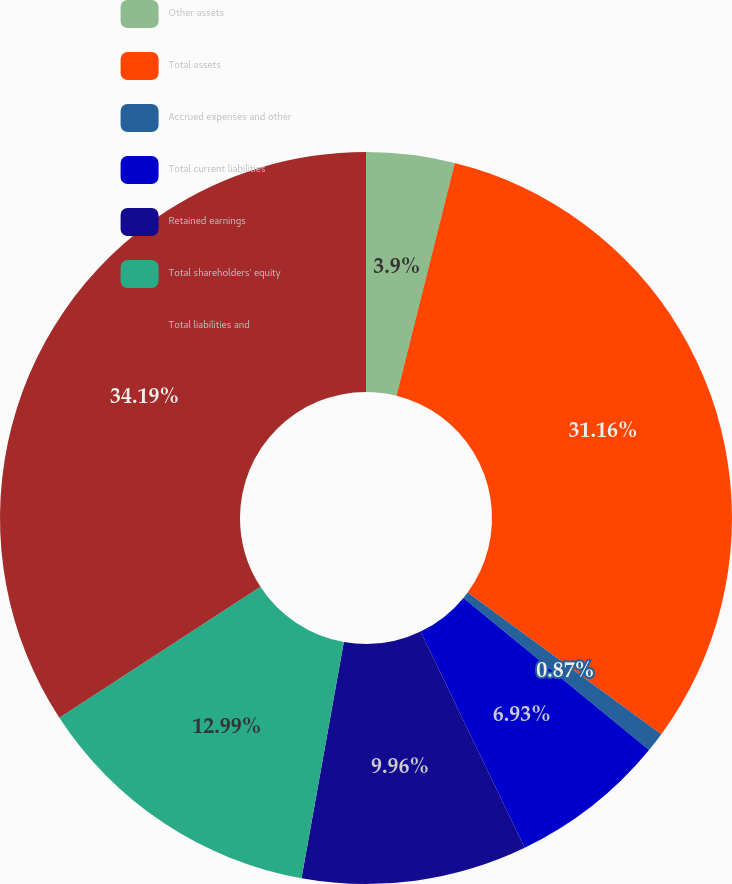<chart> <loc_0><loc_0><loc_500><loc_500><pie_chart><fcel>Other assets<fcel>Total assets<fcel>Accrued expenses and other<fcel>Total current liabilities<fcel>Retained earnings<fcel>Total shareholders' equity<fcel>Total liabilities and<nl><fcel>3.9%<fcel>31.16%<fcel>0.87%<fcel>6.93%<fcel>9.96%<fcel>12.99%<fcel>34.19%<nl></chart> 